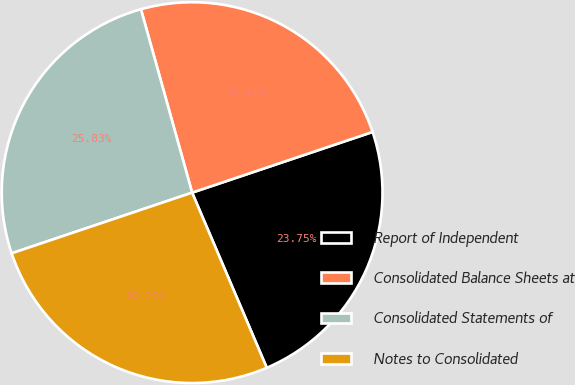Convert chart. <chart><loc_0><loc_0><loc_500><loc_500><pie_chart><fcel>Report of Independent<fcel>Consolidated Balance Sheets at<fcel>Consolidated Statements of<fcel>Notes to Consolidated<nl><fcel>23.75%<fcel>24.17%<fcel>25.83%<fcel>26.25%<nl></chart> 